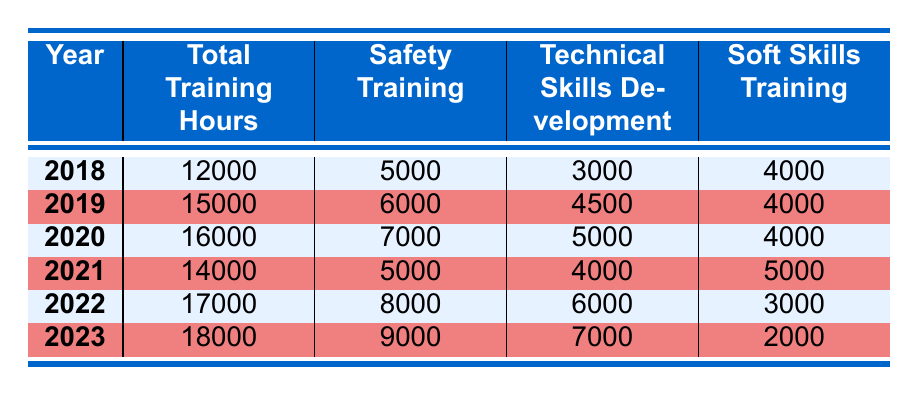What is the total number of training hours in 2020? The table shows the total training hours for each year. In the row for 2020, the value for total training hours is listed as 16000.
Answer: 16000 In which year was the highest number of hours allocated for Safety Training? By examining the Safety Training hours across the years, 2023 shows 9000 hours, which is the highest compared to other years listed.
Answer: 2023 How many total training hours were provided in 2019 compared to 2021? The total training hours for 2019 is 15000 and for 2021 is 14000. Comparison indicates that 2019 had 1000 hours more than 2021.
Answer: 1000 more in 2019 Which year had a decrease in total training hours compared to the previous year? Reviewing the total training hours year by year shows that from 2020 (16000) to 2021 (14000), there was a decrease of 2000 hours.
Answer: 2021 What is the average number of hours spent on Technical Skills Development from 2018 to 2023? To find the average, sum the technical training hours (3000 + 4500 + 5000 + 4000 + 6000 + 7000 = 32000) and divide by the number of years (6), resulting in an average of 5333.33 for Technical Skills Development over these years.
Answer: 5333.33 Was there ever a year when more than 4000 hours were spent on Soft Skills Training? Checking the Soft Skills Training hours reveals that in 2021, the hours were at 5000, which is indeed higher than 4000. Thus, the answer is yes.
Answer: Yes What is the difference in total training hours between the year with the least and the year with the most training hours? The least total training hours were in 2018 with 12000 hours, and the most were in 2023 with 18000. The difference is 18000 - 12000 = 6000.
Answer: 6000 What proportion of total training hours in 2022 were allocated to Safety Training? In 2022, total training hours were 17000, and Safety Training accounted for 8000 hours. The proportion is 8000/17000, which simplifies to approximately 0.4706 or 47.06%.
Answer: 47.06% 